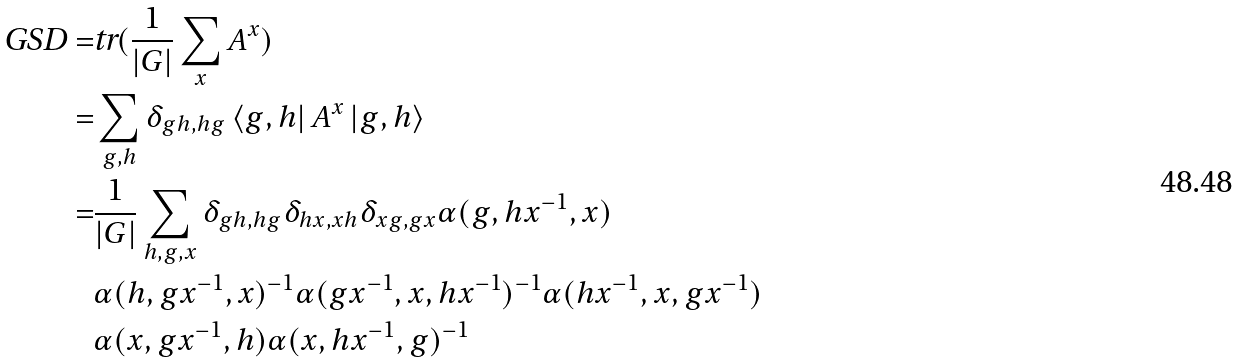Convert formula to latex. <formula><loc_0><loc_0><loc_500><loc_500>\text {GSD} = & \text {tr} ( \frac { 1 } { | G | } \sum _ { x } A ^ { x } ) \\ = & \sum _ { g , h } \delta _ { g h , h g } \left \langle g , h \right | A ^ { x } \left | g , h \right \rangle \\ = & \frac { 1 } { | G | } \sum _ { h , g , x } \delta _ { g h , h g } \delta _ { h x , x h } \delta _ { x g , g x } \alpha ( g , h x ^ { - 1 } , x ) \\ & \alpha ( h , g x ^ { - 1 } , x ) ^ { - 1 } \alpha ( g x ^ { - 1 } , x , h x ^ { - 1 } ) ^ { - 1 } \alpha ( h x ^ { - 1 } , x , g x ^ { - 1 } ) \\ & \alpha ( x , g x ^ { - 1 } , h ) \alpha ( x , h x ^ { - 1 } , g ) ^ { - 1 }</formula> 